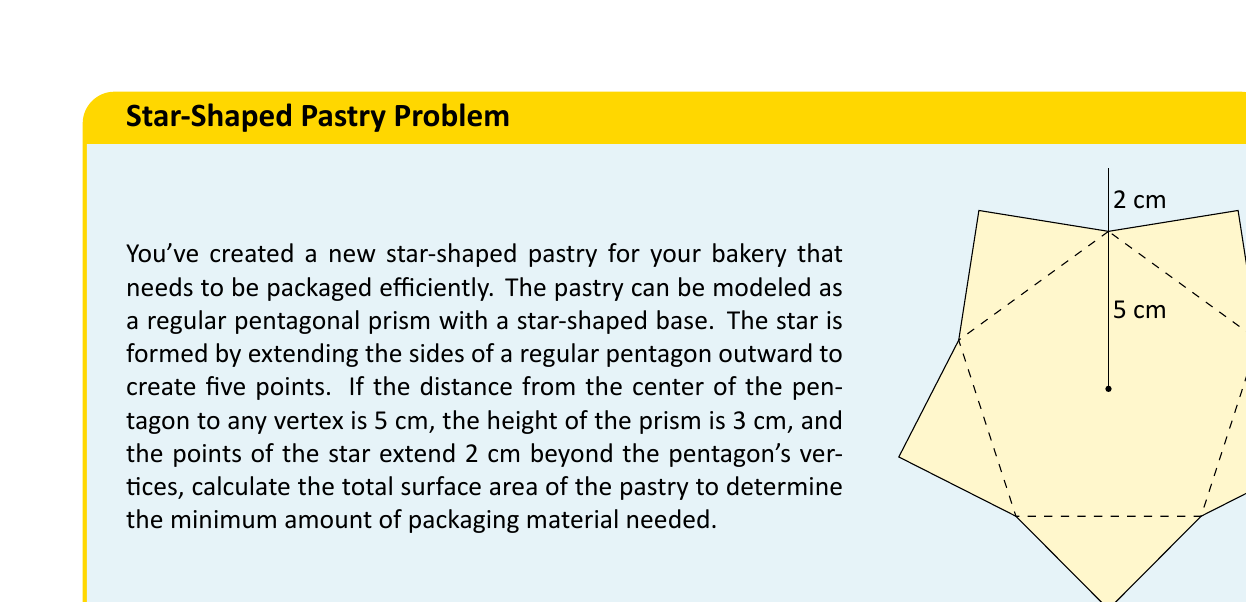Teach me how to tackle this problem. Let's break this problem down into steps:

1) First, we need to calculate the area of the star-shaped base. We can do this by finding the area of the regular pentagon and adding the areas of the triangular points.

2) For a regular pentagon with radius $r$ (distance from center to vertex), the area is given by:
   $$A_{pentagon} = \frac{5r^2}{4}\tan(36°)$$
   With $r = 5$ cm, we get:
   $$A_{pentagon} = \frac{5(5^2)}{4}\tan(36°) \approx 43.01 \text{ cm}^2$$

3) Now for each triangular point, we have a base of $2r\sin(36°)$ and a height of 2 cm. The area of each point is:
   $$A_{point} = \frac{1}{2} \cdot 2r\sin(36°) \cdot 2 = 2r\sin(36°)$$
   With $r = 5$ cm, we get:
   $$A_{point} = 2(5)\sin(36°) \approx 5.88 \text{ cm}^2$$

4) There are 5 points, so the total area of the points is:
   $$A_{total points} = 5 \cdot 5.88 = 29.40 \text{ cm}^2$$

5) The total area of the star base is:
   $$A_{star} = A_{pentagon} + A_{total points} = 43.01 + 29.40 = 72.41 \text{ cm}^2$$

6) We need two of these for the top and bottom of the prism:
   $$A_{top and bottom} = 2 \cdot 72.41 = 144.82 \text{ cm}^2$$

7) For the lateral surface area, we need the perimeter of the star shape multiplied by the height:
   Perimeter = $5 \cdot (2r\sin(36°) + 2r\sin(36°)) = 20r\sin(36°)$
   With $r = 5$ cm:
   Perimeter $\approx 58.78$ cm

8) Lateral surface area:
   $$A_{lateral} = 58.78 \cdot 3 = 176.34 \text{ cm}^2$$

9) Total surface area:
   $$A_{total} = A_{top and bottom} + A_{lateral} = 144.82 + 176.34 = 321.16 \text{ cm}^2$$
Answer: The total surface area of the star-shaped pastry is approximately $321.16 \text{ cm}^2$. 